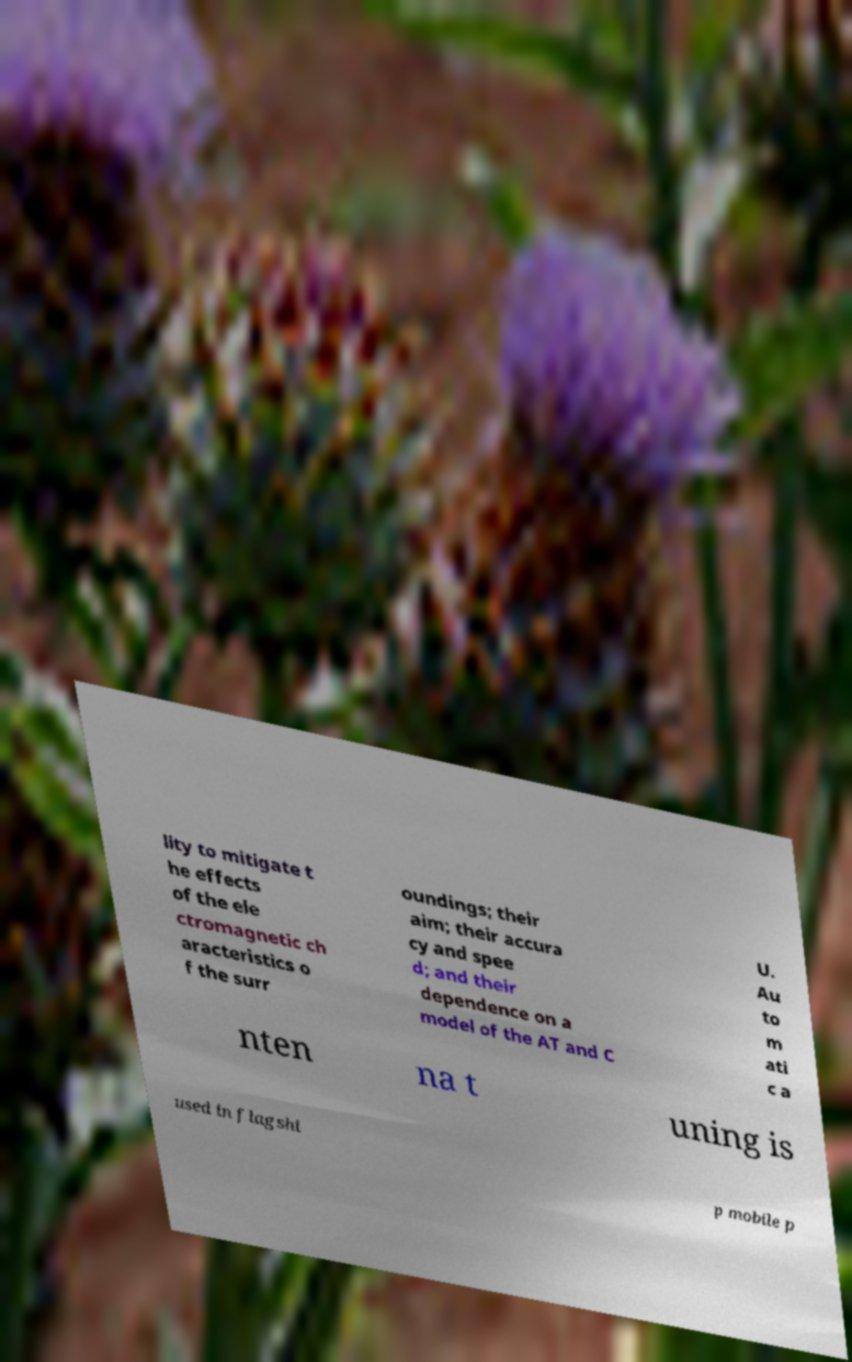Can you read and provide the text displayed in the image?This photo seems to have some interesting text. Can you extract and type it out for me? lity to mitigate t he effects of the ele ctromagnetic ch aracteristics o f the surr oundings; their aim; their accura cy and spee d; and their dependence on a model of the AT and C U. Au to m ati c a nten na t uning is used in flagshi p mobile p 